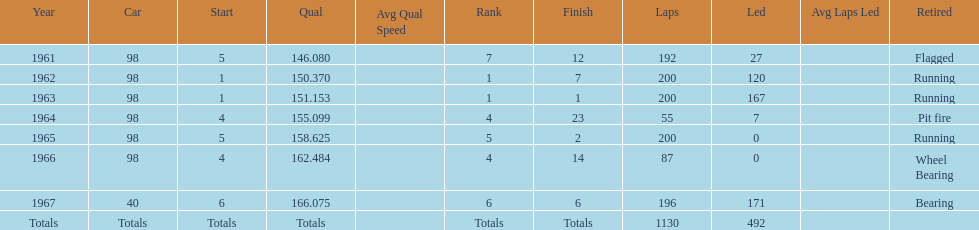What year(s) did parnelli finish at least 4th or better? 1963, 1965. 